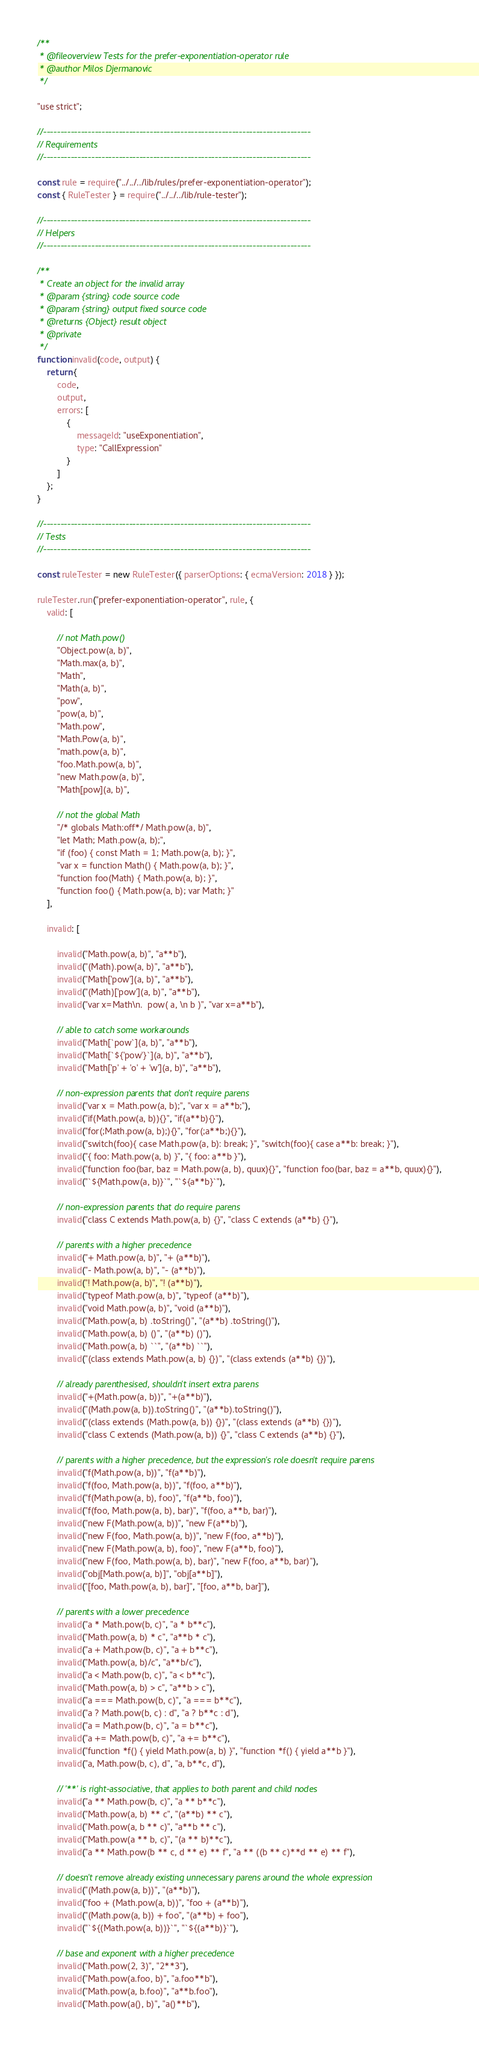Convert code to text. <code><loc_0><loc_0><loc_500><loc_500><_JavaScript_>/**
 * @fileoverview Tests for the prefer-exponentiation-operator rule
 * @author Milos Djermanovic
 */

"use strict";

//------------------------------------------------------------------------------
// Requirements
//------------------------------------------------------------------------------

const rule = require("../../../lib/rules/prefer-exponentiation-operator");
const { RuleTester } = require("../../../lib/rule-tester");

//------------------------------------------------------------------------------
// Helpers
//------------------------------------------------------------------------------

/**
 * Create an object for the invalid array
 * @param {string} code source code
 * @param {string} output fixed source code
 * @returns {Object} result object
 * @private
 */
function invalid(code, output) {
    return {
        code,
        output,
        errors: [
            {
                messageId: "useExponentiation",
                type: "CallExpression"
            }
        ]
    };
}

//------------------------------------------------------------------------------
// Tests
//------------------------------------------------------------------------------

const ruleTester = new RuleTester({ parserOptions: { ecmaVersion: 2018 } });

ruleTester.run("prefer-exponentiation-operator", rule, {
    valid: [

        // not Math.pow()
        "Object.pow(a, b)",
        "Math.max(a, b)",
        "Math",
        "Math(a, b)",
        "pow",
        "pow(a, b)",
        "Math.pow",
        "Math.Pow(a, b)",
        "math.pow(a, b)",
        "foo.Math.pow(a, b)",
        "new Math.pow(a, b)",
        "Math[pow](a, b)",

        // not the global Math
        "/* globals Math:off*/ Math.pow(a, b)",
        "let Math; Math.pow(a, b);",
        "if (foo) { const Math = 1; Math.pow(a, b); }",
        "var x = function Math() { Math.pow(a, b); }",
        "function foo(Math) { Math.pow(a, b); }",
        "function foo() { Math.pow(a, b); var Math; }"
    ],

    invalid: [

        invalid("Math.pow(a, b)", "a**b"),
        invalid("(Math).pow(a, b)", "a**b"),
        invalid("Math['pow'](a, b)", "a**b"),
        invalid("(Math)['pow'](a, b)", "a**b"),
        invalid("var x=Math\n.  pow( a, \n b )", "var x=a**b"),

        // able to catch some workarounds
        invalid("Math[`pow`](a, b)", "a**b"),
        invalid("Math[`${'pow'}`](a, b)", "a**b"),
        invalid("Math['p' + 'o' + 'w'](a, b)", "a**b"),

        // non-expression parents that don't require parens
        invalid("var x = Math.pow(a, b);", "var x = a**b;"),
        invalid("if(Math.pow(a, b)){}", "if(a**b){}"),
        invalid("for(;Math.pow(a, b);){}", "for(;a**b;){}"),
        invalid("switch(foo){ case Math.pow(a, b): break; }", "switch(foo){ case a**b: break; }"),
        invalid("{ foo: Math.pow(a, b) }", "{ foo: a**b }"),
        invalid("function foo(bar, baz = Math.pow(a, b), quux){}", "function foo(bar, baz = a**b, quux){}"),
        invalid("`${Math.pow(a, b)}`", "`${a**b}`"),

        // non-expression parents that do require parens
        invalid("class C extends Math.pow(a, b) {}", "class C extends (a**b) {}"),

        // parents with a higher precedence
        invalid("+ Math.pow(a, b)", "+ (a**b)"),
        invalid("- Math.pow(a, b)", "- (a**b)"),
        invalid("! Math.pow(a, b)", "! (a**b)"),
        invalid("typeof Math.pow(a, b)", "typeof (a**b)"),
        invalid("void Math.pow(a, b)", "void (a**b)"),
        invalid("Math.pow(a, b) .toString()", "(a**b) .toString()"),
        invalid("Math.pow(a, b) ()", "(a**b) ()"),
        invalid("Math.pow(a, b) ``", "(a**b) ``"),
        invalid("(class extends Math.pow(a, b) {})", "(class extends (a**b) {})"),

        // already parenthesised, shouldn't insert extra parens
        invalid("+(Math.pow(a, b))", "+(a**b)"),
        invalid("(Math.pow(a, b)).toString()", "(a**b).toString()"),
        invalid("(class extends (Math.pow(a, b)) {})", "(class extends (a**b) {})"),
        invalid("class C extends (Math.pow(a, b)) {}", "class C extends (a**b) {}"),

        // parents with a higher precedence, but the expression's role doesn't require parens
        invalid("f(Math.pow(a, b))", "f(a**b)"),
        invalid("f(foo, Math.pow(a, b))", "f(foo, a**b)"),
        invalid("f(Math.pow(a, b), foo)", "f(a**b, foo)"),
        invalid("f(foo, Math.pow(a, b), bar)", "f(foo, a**b, bar)"),
        invalid("new F(Math.pow(a, b))", "new F(a**b)"),
        invalid("new F(foo, Math.pow(a, b))", "new F(foo, a**b)"),
        invalid("new F(Math.pow(a, b), foo)", "new F(a**b, foo)"),
        invalid("new F(foo, Math.pow(a, b), bar)", "new F(foo, a**b, bar)"),
        invalid("obj[Math.pow(a, b)]", "obj[a**b]"),
        invalid("[foo, Math.pow(a, b), bar]", "[foo, a**b, bar]"),

        // parents with a lower precedence
        invalid("a * Math.pow(b, c)", "a * b**c"),
        invalid("Math.pow(a, b) * c", "a**b * c"),
        invalid("a + Math.pow(b, c)", "a + b**c"),
        invalid("Math.pow(a, b)/c", "a**b/c"),
        invalid("a < Math.pow(b, c)", "a < b**c"),
        invalid("Math.pow(a, b) > c", "a**b > c"),
        invalid("a === Math.pow(b, c)", "a === b**c"),
        invalid("a ? Math.pow(b, c) : d", "a ? b**c : d"),
        invalid("a = Math.pow(b, c)", "a = b**c"),
        invalid("a += Math.pow(b, c)", "a += b**c"),
        invalid("function *f() { yield Math.pow(a, b) }", "function *f() { yield a**b }"),
        invalid("a, Math.pow(b, c), d", "a, b**c, d"),

        // '**' is right-associative, that applies to both parent and child nodes
        invalid("a ** Math.pow(b, c)", "a ** b**c"),
        invalid("Math.pow(a, b) ** c", "(a**b) ** c"),
        invalid("Math.pow(a, b ** c)", "a**b ** c"),
        invalid("Math.pow(a ** b, c)", "(a ** b)**c"),
        invalid("a ** Math.pow(b ** c, d ** e) ** f", "a ** ((b ** c)**d ** e) ** f"),

        // doesn't remove already existing unnecessary parens around the whole expression
        invalid("(Math.pow(a, b))", "(a**b)"),
        invalid("foo + (Math.pow(a, b))", "foo + (a**b)"),
        invalid("(Math.pow(a, b)) + foo", "(a**b) + foo"),
        invalid("`${(Math.pow(a, b))}`", "`${(a**b)}`"),

        // base and exponent with a higher precedence
        invalid("Math.pow(2, 3)", "2**3"),
        invalid("Math.pow(a.foo, b)", "a.foo**b"),
        invalid("Math.pow(a, b.foo)", "a**b.foo"),
        invalid("Math.pow(a(), b)", "a()**b"),</code> 